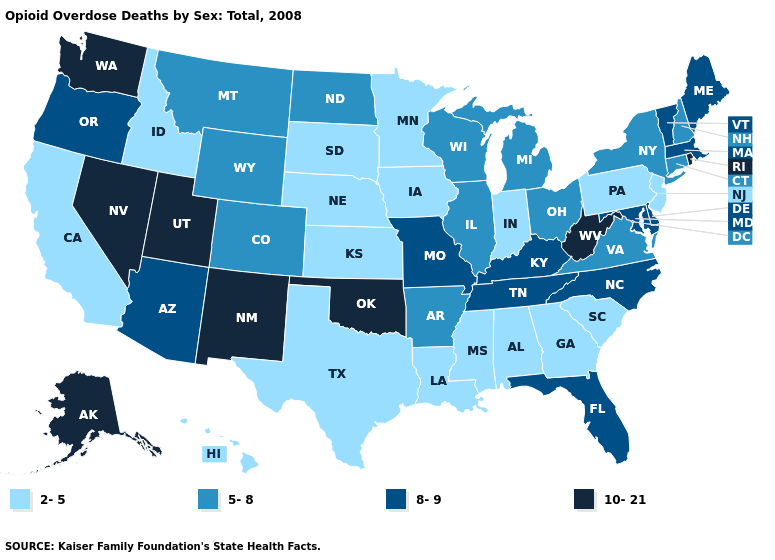Which states hav the highest value in the West?
Be succinct. Alaska, Nevada, New Mexico, Utah, Washington. What is the lowest value in the USA?
Write a very short answer. 2-5. Does Washington have the same value as Utah?
Quick response, please. Yes. How many symbols are there in the legend?
Write a very short answer. 4. Does the map have missing data?
Short answer required. No. Does the map have missing data?
Write a very short answer. No. Does Alaska have the highest value in the USA?
Keep it brief. Yes. What is the value of Florida?
Short answer required. 8-9. What is the value of North Dakota?
Concise answer only. 5-8. Among the states that border Oklahoma , which have the highest value?
Concise answer only. New Mexico. Among the states that border Nebraska , does Missouri have the lowest value?
Quick response, please. No. Which states have the lowest value in the Northeast?
Write a very short answer. New Jersey, Pennsylvania. Which states hav the highest value in the South?
Quick response, please. Oklahoma, West Virginia. Name the states that have a value in the range 10-21?
Concise answer only. Alaska, Nevada, New Mexico, Oklahoma, Rhode Island, Utah, Washington, West Virginia. Does Indiana have the same value as Georgia?
Keep it brief. Yes. 